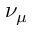Convert formula to latex. <formula><loc_0><loc_0><loc_500><loc_500>\nu _ { \mu }</formula> 